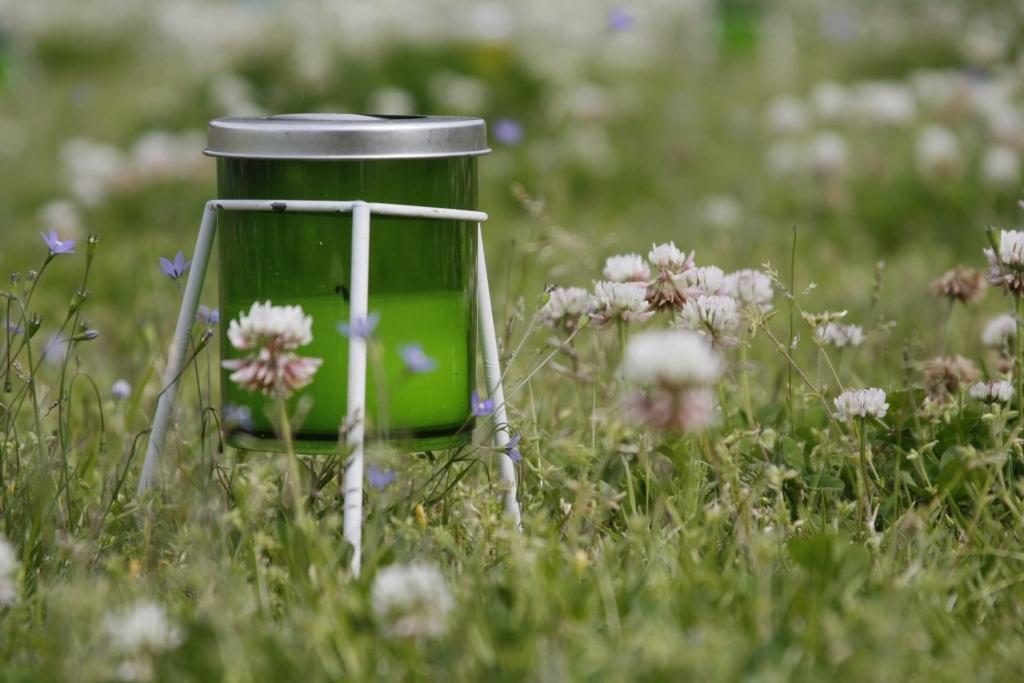Please provide a concise description of this image. In this image there is a jar attached to the stand, there are a few flowers and plants. 